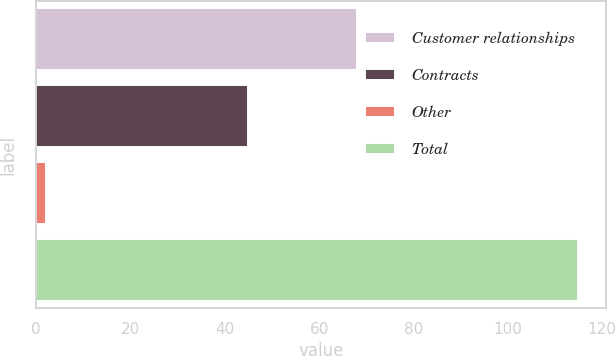Convert chart to OTSL. <chart><loc_0><loc_0><loc_500><loc_500><bar_chart><fcel>Customer relationships<fcel>Contracts<fcel>Other<fcel>Total<nl><fcel>68<fcel>45<fcel>2<fcel>115<nl></chart> 